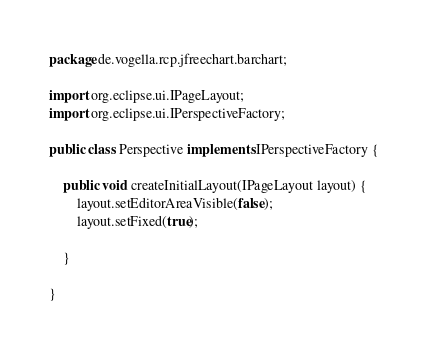Convert code to text. <code><loc_0><loc_0><loc_500><loc_500><_Java_>package de.vogella.rcp.jfreechart.barchart;

import org.eclipse.ui.IPageLayout;
import org.eclipse.ui.IPerspectiveFactory;

public class Perspective implements IPerspectiveFactory {

	public void createInitialLayout(IPageLayout layout) {
		layout.setEditorAreaVisible(false);
		layout.setFixed(true);
		
	}

}
</code> 